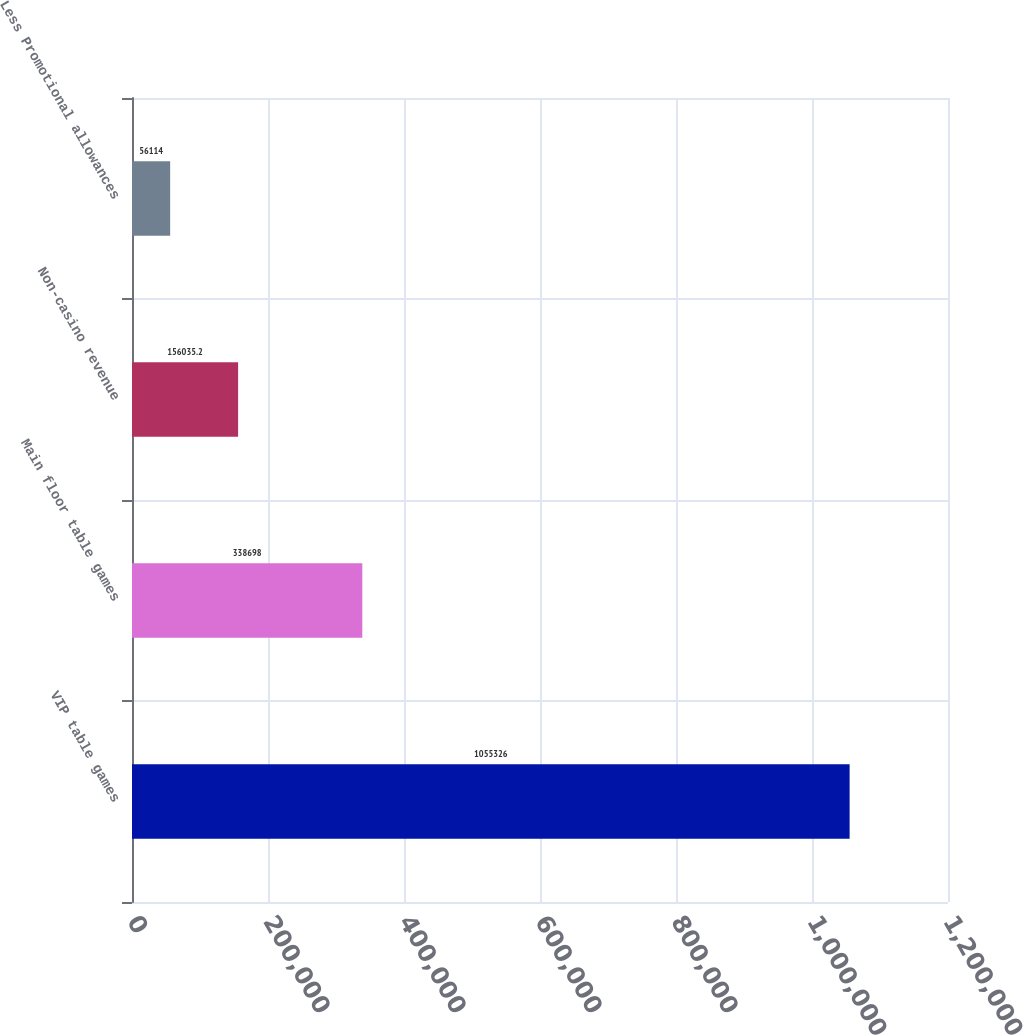Convert chart. <chart><loc_0><loc_0><loc_500><loc_500><bar_chart><fcel>VIP table games<fcel>Main floor table games<fcel>Non-casino revenue<fcel>Less Promotional allowances<nl><fcel>1.05533e+06<fcel>338698<fcel>156035<fcel>56114<nl></chart> 